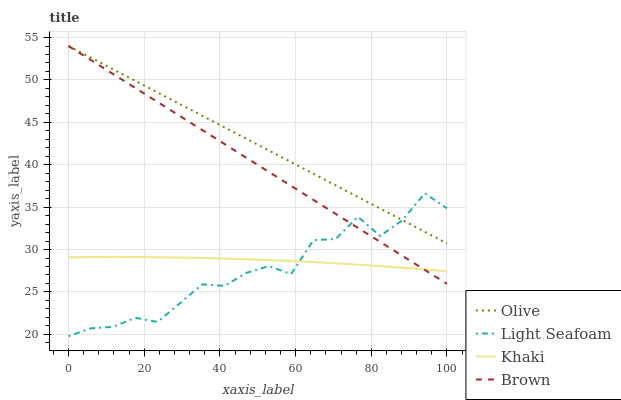Does Light Seafoam have the minimum area under the curve?
Answer yes or no. Yes. Does Olive have the maximum area under the curve?
Answer yes or no. Yes. Does Brown have the minimum area under the curve?
Answer yes or no. No. Does Brown have the maximum area under the curve?
Answer yes or no. No. Is Brown the smoothest?
Answer yes or no. Yes. Is Light Seafoam the roughest?
Answer yes or no. Yes. Is Light Seafoam the smoothest?
Answer yes or no. No. Is Brown the roughest?
Answer yes or no. No. Does Light Seafoam have the lowest value?
Answer yes or no. Yes. Does Brown have the lowest value?
Answer yes or no. No. Does Brown have the highest value?
Answer yes or no. Yes. Does Light Seafoam have the highest value?
Answer yes or no. No. Is Khaki less than Olive?
Answer yes or no. Yes. Is Olive greater than Khaki?
Answer yes or no. Yes. Does Olive intersect Light Seafoam?
Answer yes or no. Yes. Is Olive less than Light Seafoam?
Answer yes or no. No. Is Olive greater than Light Seafoam?
Answer yes or no. No. Does Khaki intersect Olive?
Answer yes or no. No. 